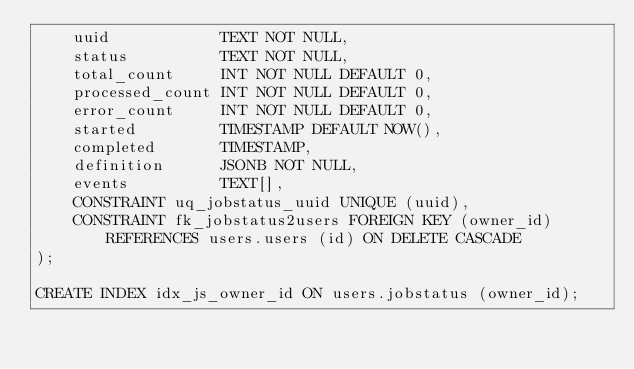<code> <loc_0><loc_0><loc_500><loc_500><_SQL_>    uuid            TEXT NOT NULL,
    status          TEXT NOT NULL,
    total_count     INT NOT NULL DEFAULT 0,
    processed_count INT NOT NULL DEFAULT 0,
    error_count     INT NOT NULL DEFAULT 0,
    started         TIMESTAMP DEFAULT NOW(),
    completed       TIMESTAMP,
    definition      JSONB NOT NULL,
    events          TEXT[],
    CONSTRAINT uq_jobstatus_uuid UNIQUE (uuid),
    CONSTRAINT fk_jobstatus2users FOREIGN KEY (owner_id) REFERENCES users.users (id) ON DELETE CASCADE
);

CREATE INDEX idx_js_owner_id ON users.jobstatus (owner_id);
</code> 